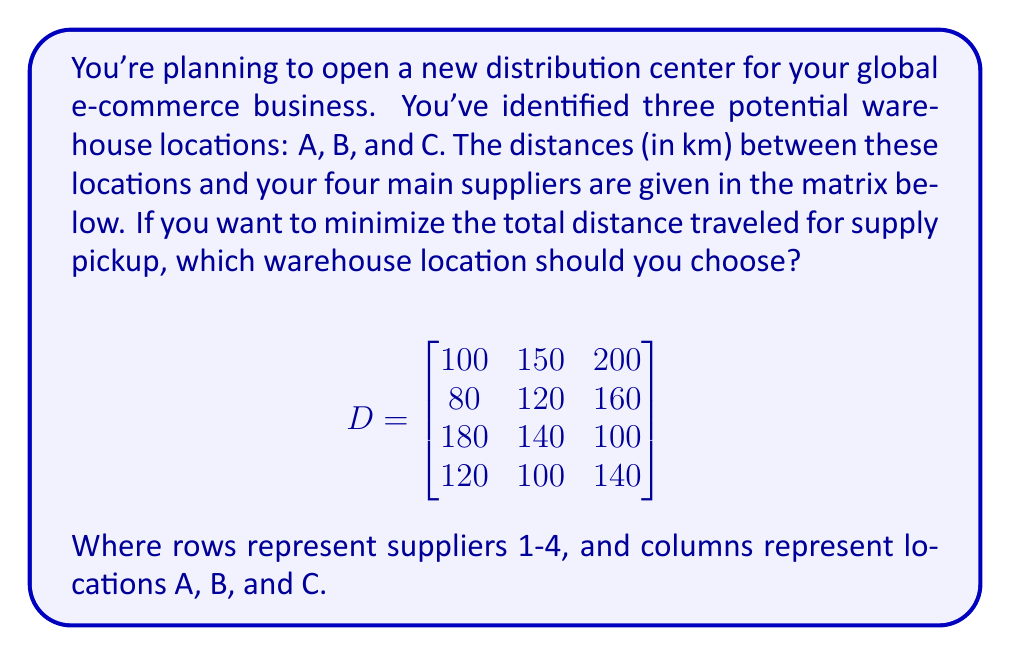Can you answer this question? To find the optimal warehouse location, we need to calculate the total distance for each location and choose the one with the minimum total distance. Let's solve this step-by-step:

1. Calculate the total distance for location A:
   $$ D_A = 100 + 80 + 180 + 120 = 480 \text{ km} $$

2. Calculate the total distance for location B:
   $$ D_B = 150 + 120 + 140 + 100 = 510 \text{ km} $$

3. Calculate the total distance for location C:
   $$ D_C = 200 + 160 + 100 + 140 = 600 \text{ km} $$

4. Compare the total distances:
   $$ D_A = 480 \text{ km} < D_B = 510 \text{ km} < D_C = 600 \text{ km} $$

5. The location with the minimum total distance is A with 480 km.

Therefore, to minimize the total distance traveled for supply pickup, you should choose warehouse location A.
Answer: Location A 